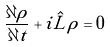<formula> <loc_0><loc_0><loc_500><loc_500>\frac { \partial \rho } { \partial t } + i \hat { L } \rho = 0</formula> 